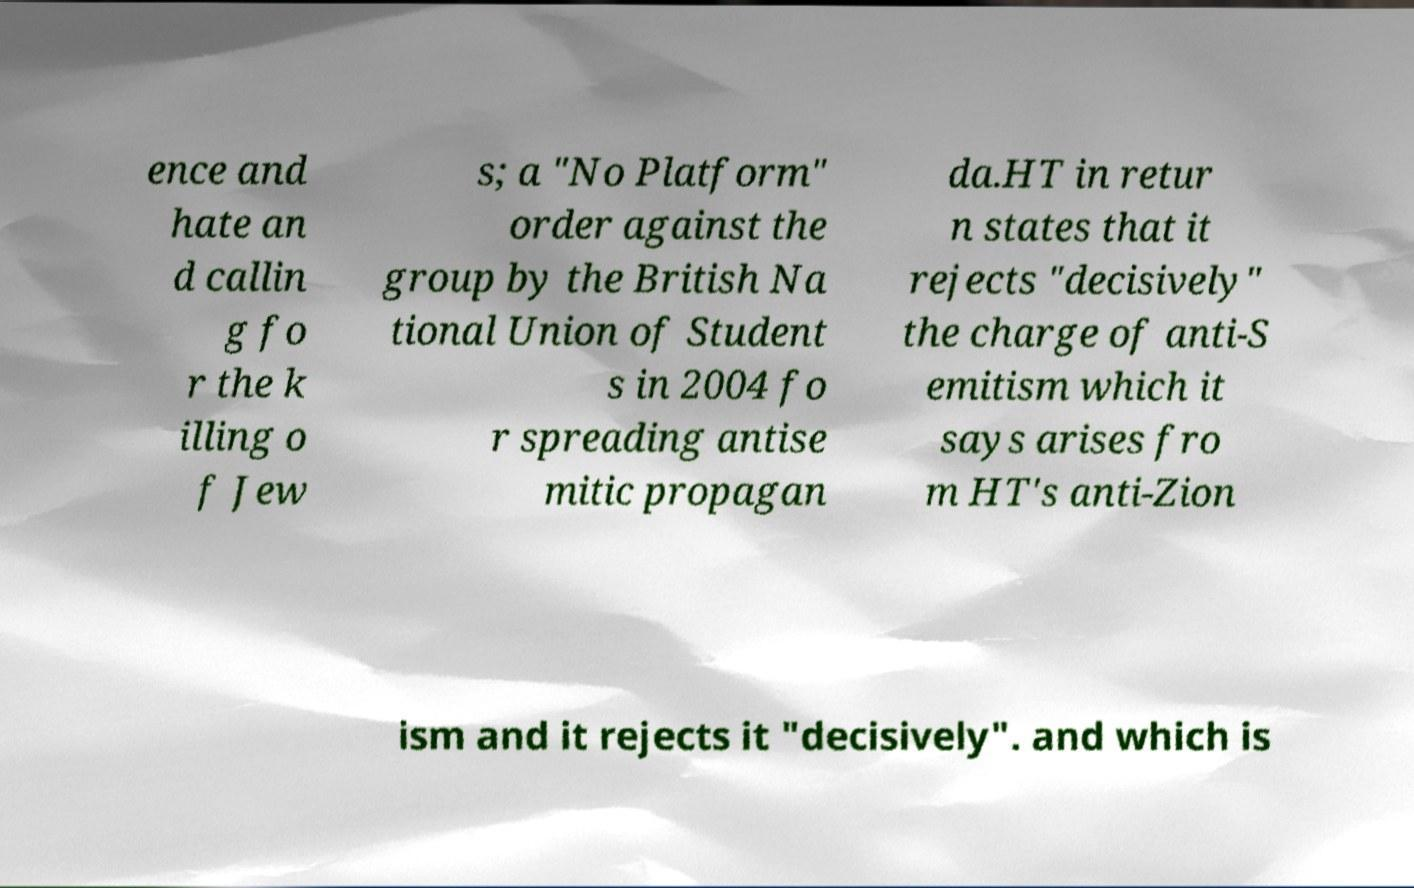I need the written content from this picture converted into text. Can you do that? ence and hate an d callin g fo r the k illing o f Jew s; a "No Platform" order against the group by the British Na tional Union of Student s in 2004 fo r spreading antise mitic propagan da.HT in retur n states that it rejects "decisively" the charge of anti-S emitism which it says arises fro m HT's anti-Zion ism and it rejects it "decisively". and which is 